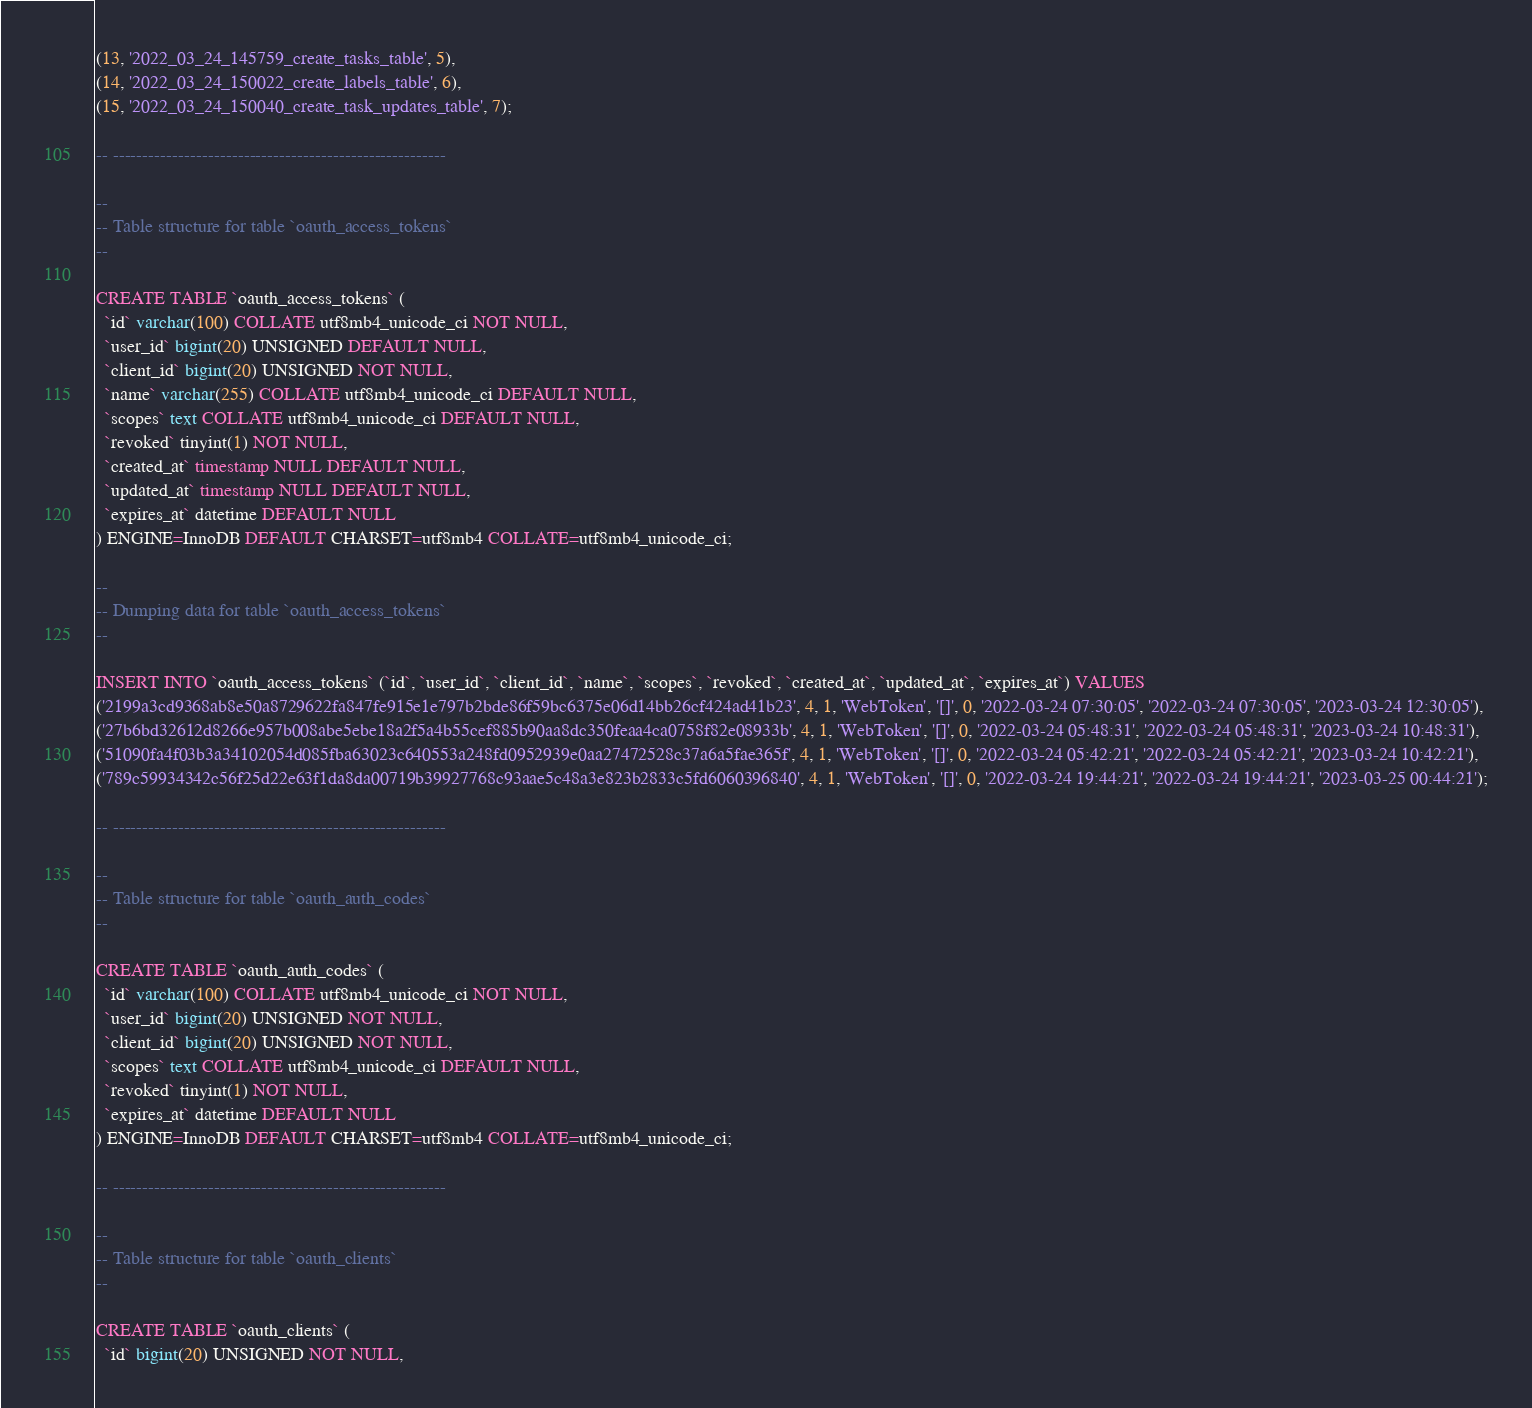<code> <loc_0><loc_0><loc_500><loc_500><_SQL_>(13, '2022_03_24_145759_create_tasks_table', 5),
(14, '2022_03_24_150022_create_labels_table', 6),
(15, '2022_03_24_150040_create_task_updates_table', 7);

-- --------------------------------------------------------

--
-- Table structure for table `oauth_access_tokens`
--

CREATE TABLE `oauth_access_tokens` (
  `id` varchar(100) COLLATE utf8mb4_unicode_ci NOT NULL,
  `user_id` bigint(20) UNSIGNED DEFAULT NULL,
  `client_id` bigint(20) UNSIGNED NOT NULL,
  `name` varchar(255) COLLATE utf8mb4_unicode_ci DEFAULT NULL,
  `scopes` text COLLATE utf8mb4_unicode_ci DEFAULT NULL,
  `revoked` tinyint(1) NOT NULL,
  `created_at` timestamp NULL DEFAULT NULL,
  `updated_at` timestamp NULL DEFAULT NULL,
  `expires_at` datetime DEFAULT NULL
) ENGINE=InnoDB DEFAULT CHARSET=utf8mb4 COLLATE=utf8mb4_unicode_ci;

--
-- Dumping data for table `oauth_access_tokens`
--

INSERT INTO `oauth_access_tokens` (`id`, `user_id`, `client_id`, `name`, `scopes`, `revoked`, `created_at`, `updated_at`, `expires_at`) VALUES
('2199a3cd9368ab8e50a8729622fa847fe915e1e797b2bde86f59bc6375e06d14bb26cf424ad41b23', 4, 1, 'WebToken', '[]', 0, '2022-03-24 07:30:05', '2022-03-24 07:30:05', '2023-03-24 12:30:05'),
('27b6bd32612d8266e957b008abe5ebe18a2f5a4b55cef885b90aa8dc350feaa4ca0758f82e08933b', 4, 1, 'WebToken', '[]', 0, '2022-03-24 05:48:31', '2022-03-24 05:48:31', '2023-03-24 10:48:31'),
('51090fa4f03b3a34102054d085fba63023c640553a248fd0952939e0aa27472528c37a6a5fae365f', 4, 1, 'WebToken', '[]', 0, '2022-03-24 05:42:21', '2022-03-24 05:42:21', '2023-03-24 10:42:21'),
('789c59934342c56f25d22e63f1da8da00719b39927768c93aae5c48a3e823b2833c5fd6060396840', 4, 1, 'WebToken', '[]', 0, '2022-03-24 19:44:21', '2022-03-24 19:44:21', '2023-03-25 00:44:21');

-- --------------------------------------------------------

--
-- Table structure for table `oauth_auth_codes`
--

CREATE TABLE `oauth_auth_codes` (
  `id` varchar(100) COLLATE utf8mb4_unicode_ci NOT NULL,
  `user_id` bigint(20) UNSIGNED NOT NULL,
  `client_id` bigint(20) UNSIGNED NOT NULL,
  `scopes` text COLLATE utf8mb4_unicode_ci DEFAULT NULL,
  `revoked` tinyint(1) NOT NULL,
  `expires_at` datetime DEFAULT NULL
) ENGINE=InnoDB DEFAULT CHARSET=utf8mb4 COLLATE=utf8mb4_unicode_ci;

-- --------------------------------------------------------

--
-- Table structure for table `oauth_clients`
--

CREATE TABLE `oauth_clients` (
  `id` bigint(20) UNSIGNED NOT NULL,</code> 